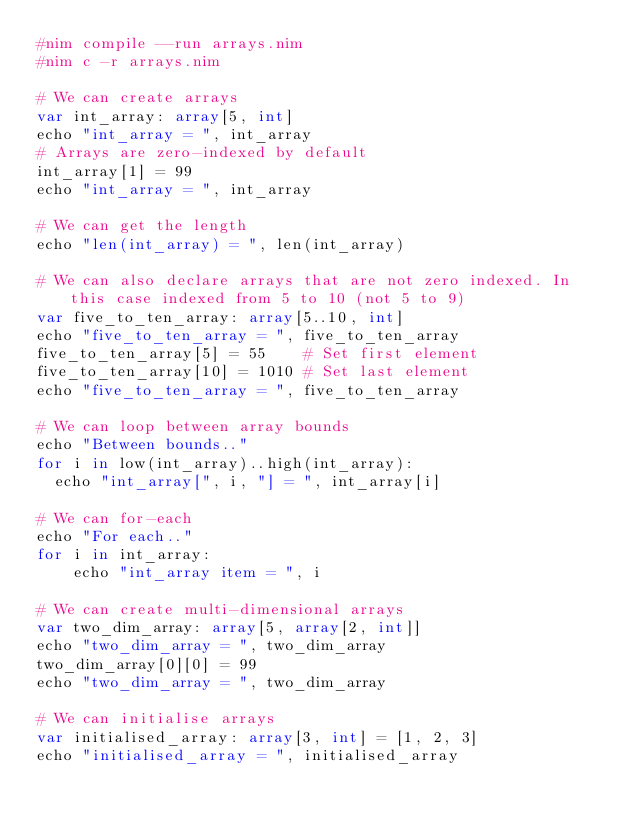Convert code to text. <code><loc_0><loc_0><loc_500><loc_500><_Nim_>#nim compile --run arrays.nim
#nim c -r arrays.nim

# We can create arrays
var int_array: array[5, int]
echo "int_array = ", int_array
# Arrays are zero-indexed by default
int_array[1] = 99
echo "int_array = ", int_array

# We can get the length
echo "len(int_array) = ", len(int_array)

# We can also declare arrays that are not zero indexed. In this case indexed from 5 to 10 (not 5 to 9)
var five_to_ten_array: array[5..10, int]
echo "five_to_ten_array = ", five_to_ten_array
five_to_ten_array[5] = 55    # Set first element
five_to_ten_array[10] = 1010 # Set last element
echo "five_to_ten_array = ", five_to_ten_array

# We can loop between array bounds
echo "Between bounds.."
for i in low(int_array)..high(int_array):
  echo "int_array[", i, "] = ", int_array[i]
  
# We can for-each
echo "For each.."
for i in int_array:
    echo "int_array item = ", i

# We can create multi-dimensional arrays
var two_dim_array: array[5, array[2, int]]
echo "two_dim_array = ", two_dim_array
two_dim_array[0][0] = 99
echo "two_dim_array = ", two_dim_array

# We can initialise arrays
var initialised_array: array[3, int] = [1, 2, 3]
echo "initialised_array = ", initialised_array</code> 